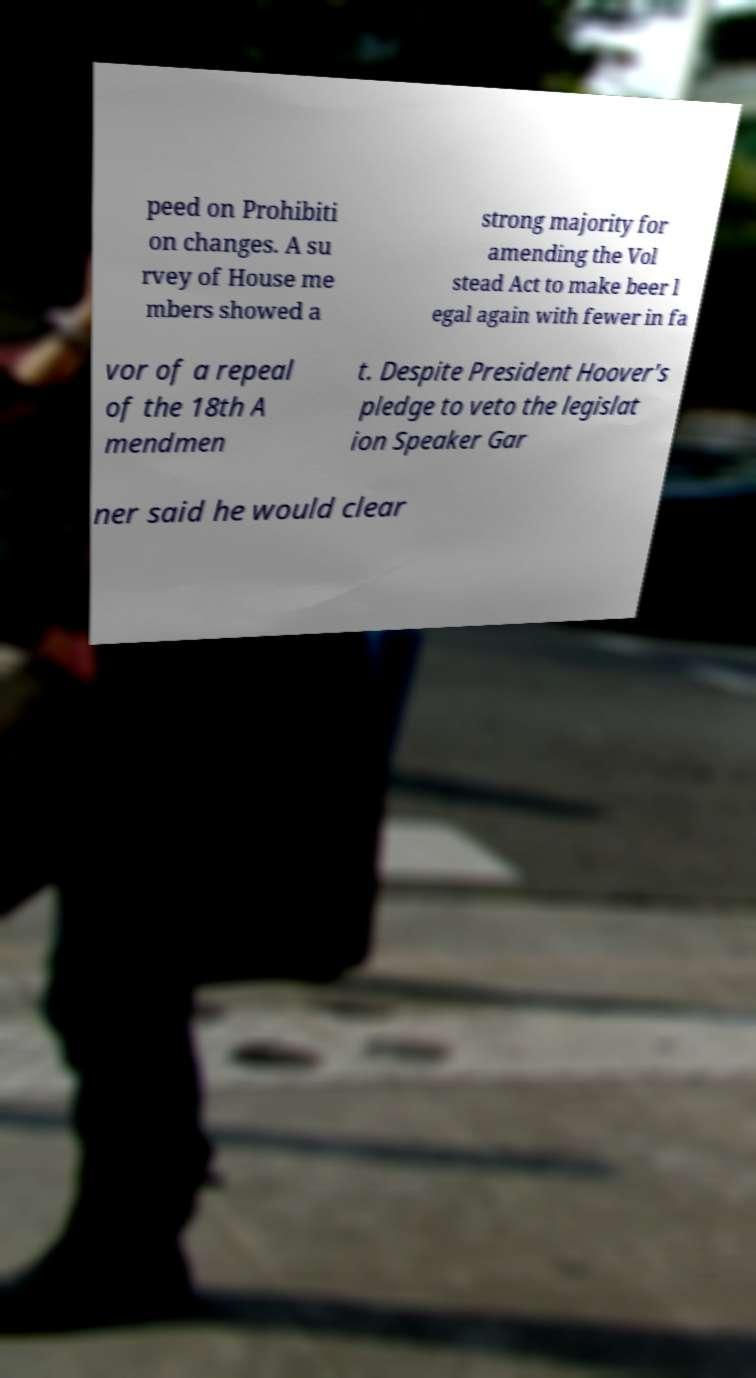Can you accurately transcribe the text from the provided image for me? peed on Prohibiti on changes. A su rvey of House me mbers showed a strong majority for amending the Vol stead Act to make beer l egal again with fewer in fa vor of a repeal of the 18th A mendmen t. Despite President Hoover's pledge to veto the legislat ion Speaker Gar ner said he would clear 